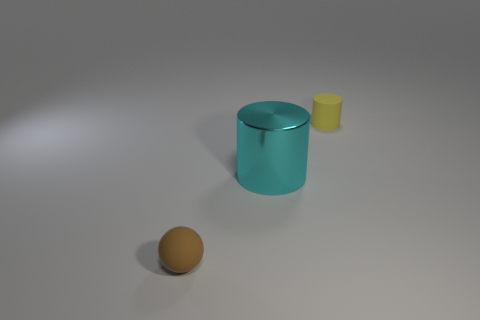Subtract 2 cylinders. How many cylinders are left? 0 Add 1 balls. How many objects exist? 4 Subtract all cyan cylinders. How many cylinders are left? 1 Subtract all spheres. How many objects are left? 2 Subtract all blue balls. How many purple cylinders are left? 0 Add 3 tiny purple shiny objects. How many tiny purple shiny objects exist? 3 Subtract 0 purple spheres. How many objects are left? 3 Subtract all yellow cylinders. Subtract all red balls. How many cylinders are left? 1 Subtract all brown matte things. Subtract all tiny spheres. How many objects are left? 1 Add 1 small yellow things. How many small yellow things are left? 2 